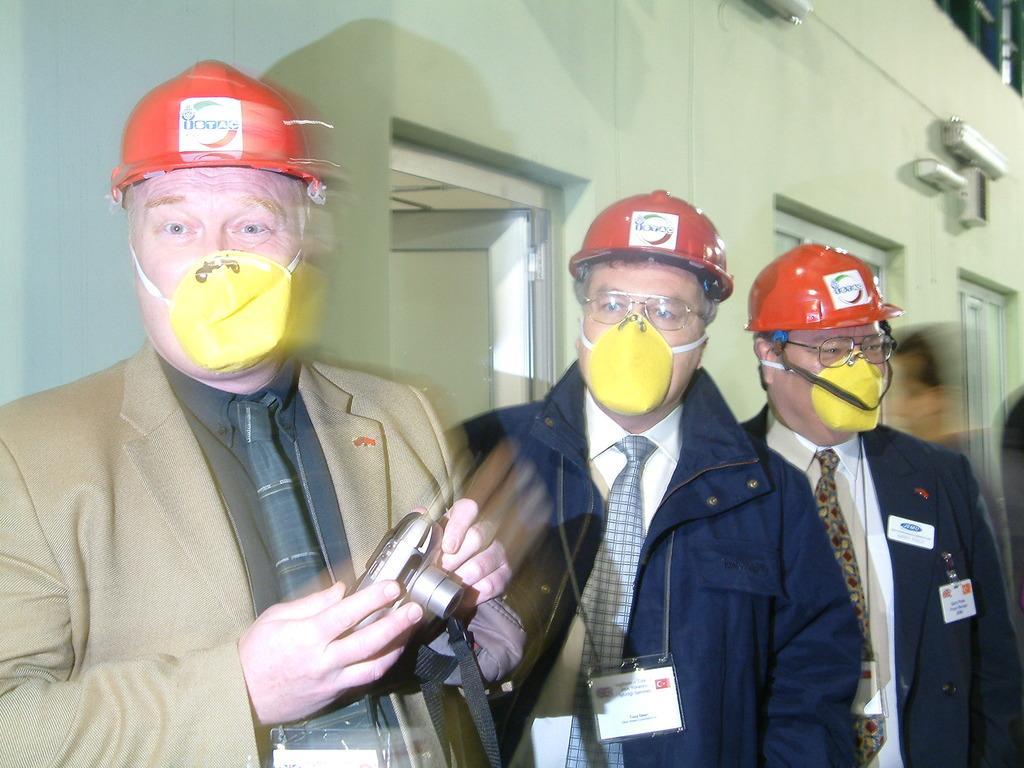In one or two sentences, can you explain what this image depicts? In this image there are three men standing, wearing masks on their face and helmets, the first person is holding a camera in his hand, behind them there are doors on the wall. 